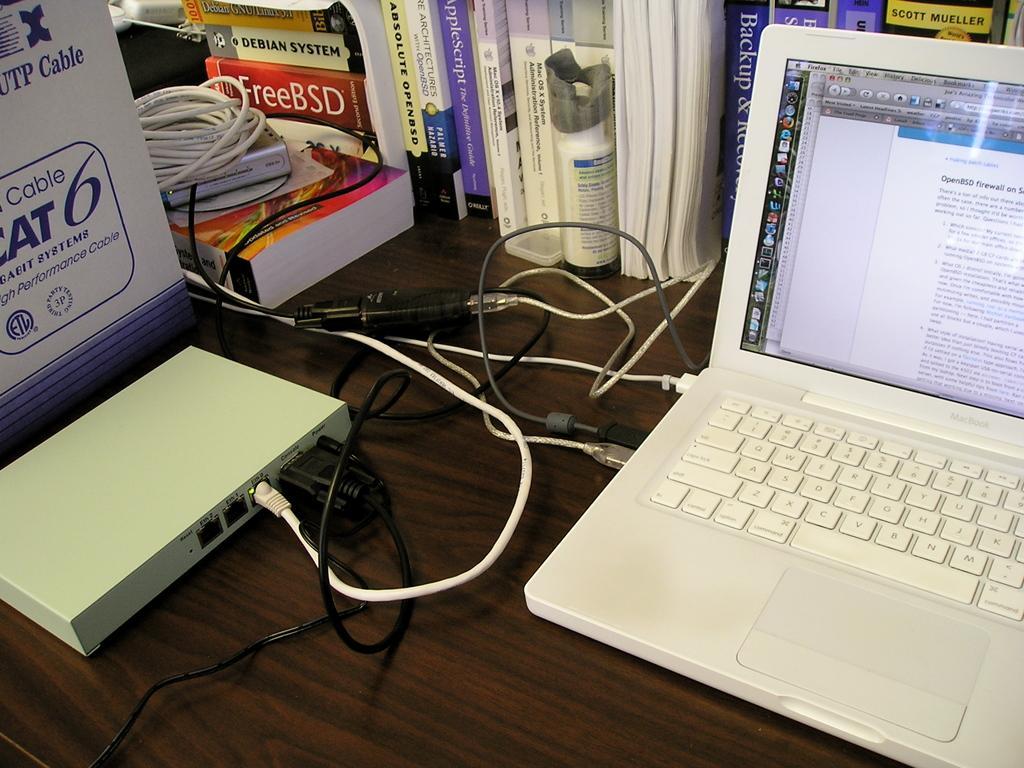Could you give a brief overview of what you see in this image? This is the picture of the table where we have some books, system and a cable connector. 